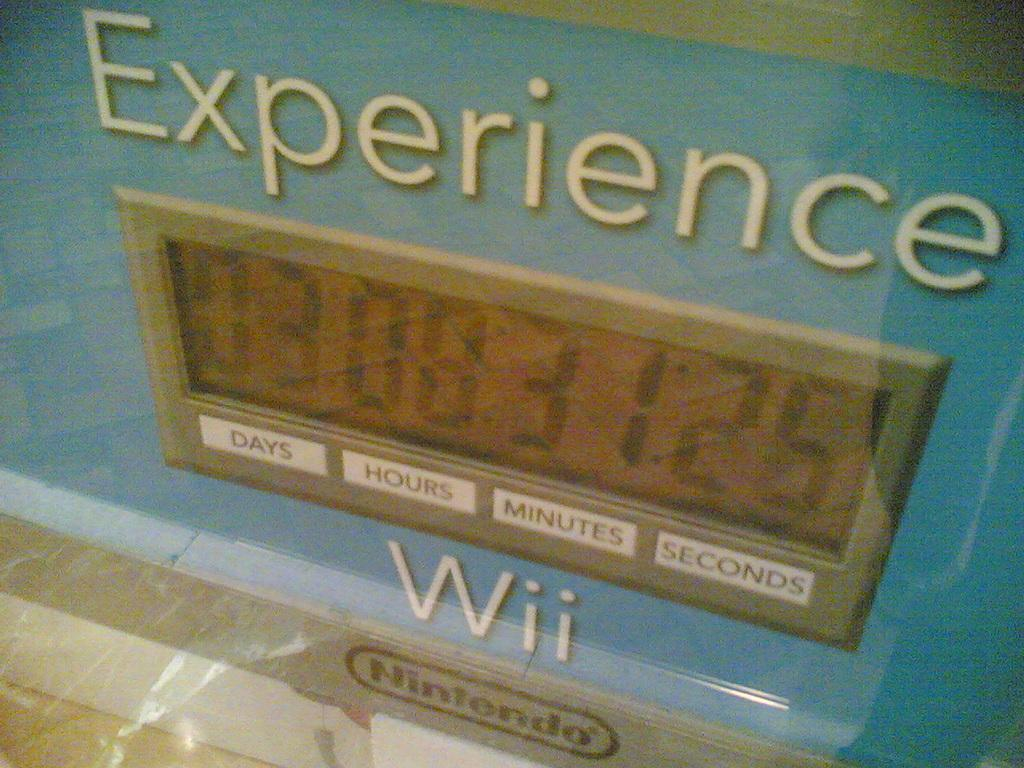Provide a one-sentence caption for the provided image. Blue sign that says "Experience Wii" on it. 